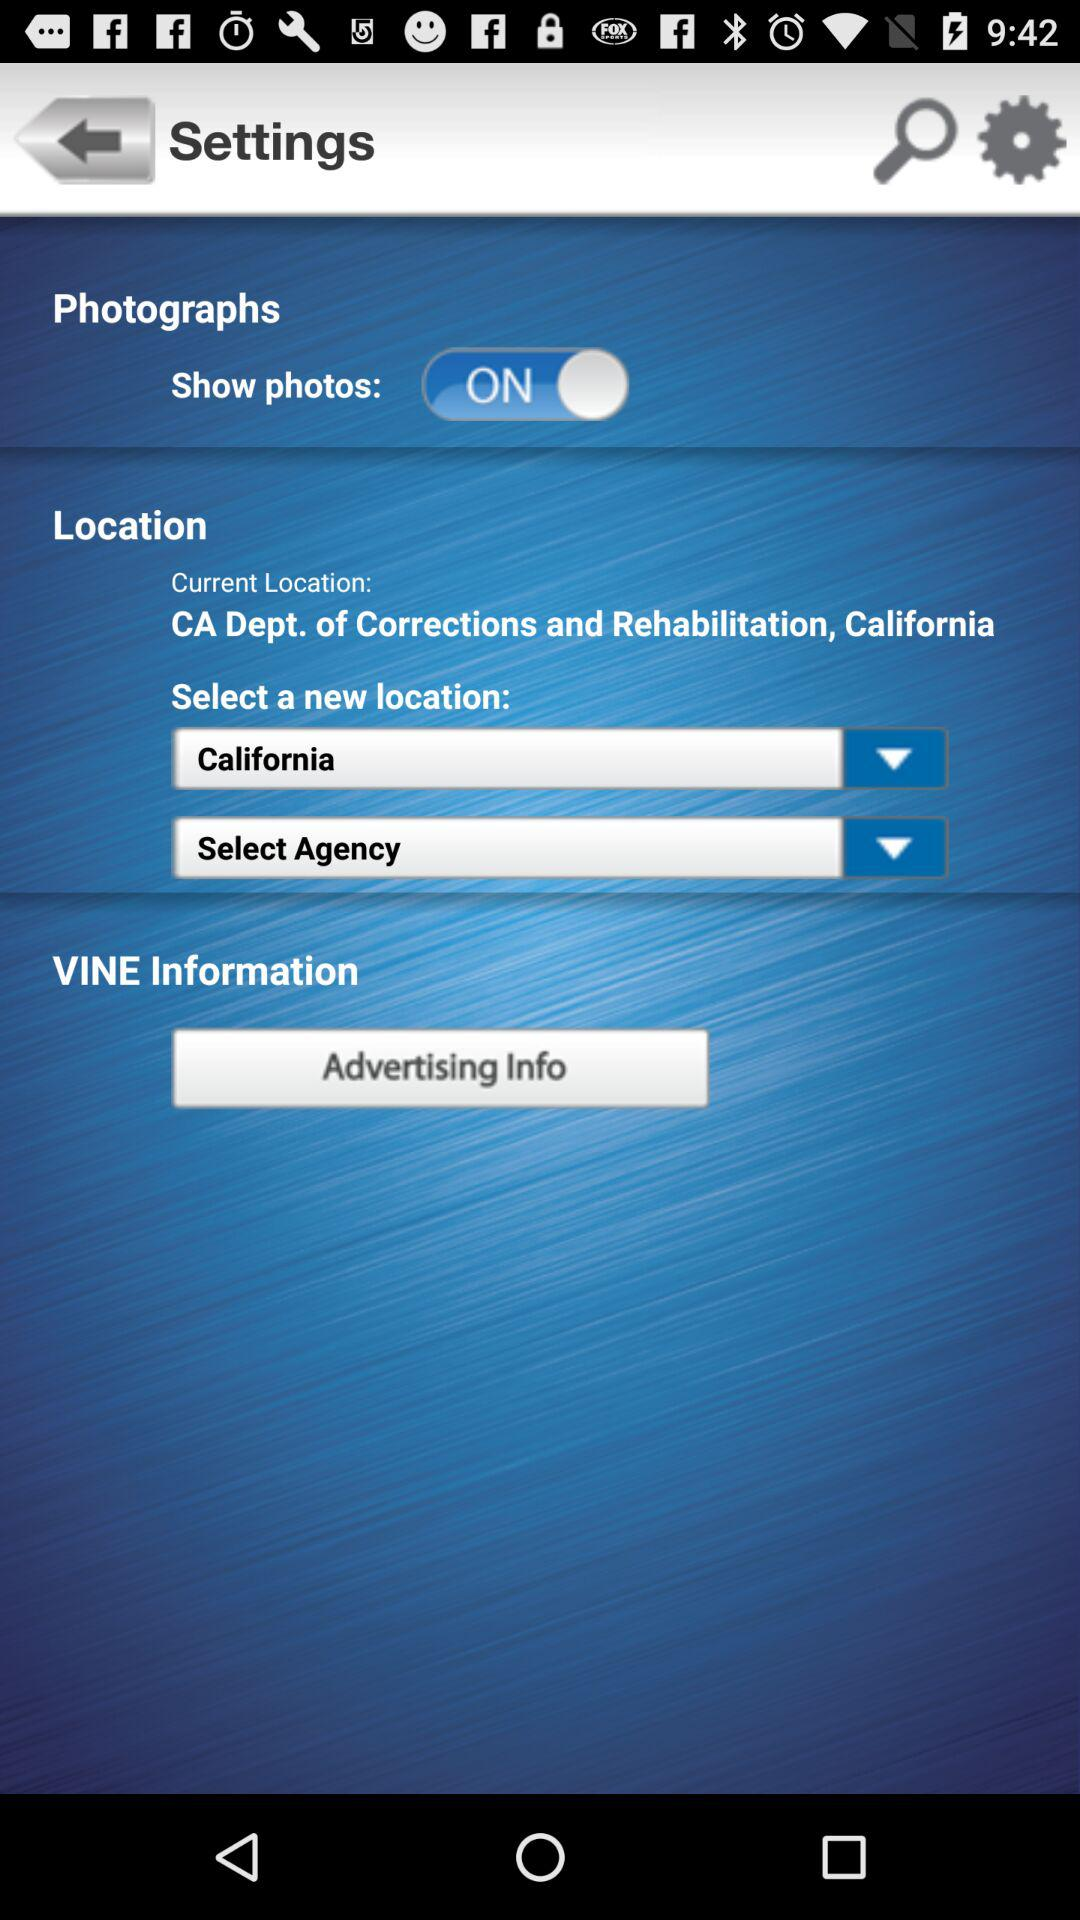At what location is the person currently? The person is currently at the California Department of Corrections and Rehabilitation. 